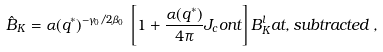<formula> <loc_0><loc_0><loc_500><loc_500>\hat { B } _ { K } = \alpha ( q ^ { * } ) ^ { - \gamma _ { 0 } / 2 \beta _ { 0 } } \, \left [ 1 + \frac { \alpha ( q ^ { * } ) } { 4 \pi } J _ { c } o n t \right ] B _ { K } ^ { l } a t , s u b t r a c t e d \, ,</formula> 